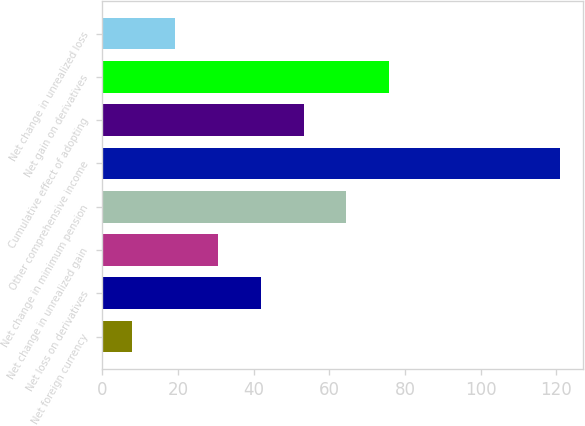Convert chart. <chart><loc_0><loc_0><loc_500><loc_500><bar_chart><fcel>Net foreign currency<fcel>Net loss on derivatives<fcel>Net change in unrealized gain<fcel>Net change in minimum pension<fcel>Other comprehensive income<fcel>Cumulative effect of adopting<fcel>Net gain on derivatives<fcel>Net change in unrealized loss<nl><fcel>8<fcel>41.9<fcel>30.6<fcel>64.5<fcel>121<fcel>53.2<fcel>75.8<fcel>19.3<nl></chart> 